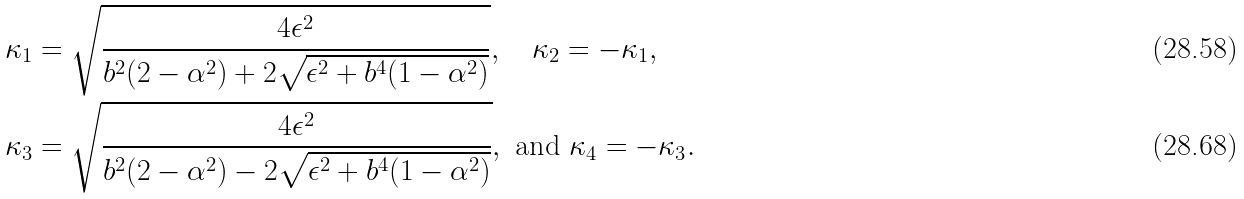Convert formula to latex. <formula><loc_0><loc_0><loc_500><loc_500>\kappa _ { 1 } & = \sqrt { \frac { 4 \epsilon ^ { 2 } } { b ^ { 2 } ( 2 - \alpha ^ { 2 } ) + 2 \sqrt { \epsilon ^ { 2 } + b ^ { 4 } ( 1 - \alpha ^ { 2 } ) } } } , \quad \kappa _ { 2 } = - \kappa _ { 1 } , \\ \kappa _ { 3 } & = \sqrt { \frac { 4 \epsilon ^ { 2 } } { b ^ { 2 } ( 2 - \alpha ^ { 2 } ) - 2 \sqrt { \epsilon ^ { 2 } + b ^ { 4 } ( 1 - \alpha ^ { 2 } ) } } } , \ \text {and } \kappa _ { 4 } = - \kappa _ { 3 } .</formula> 